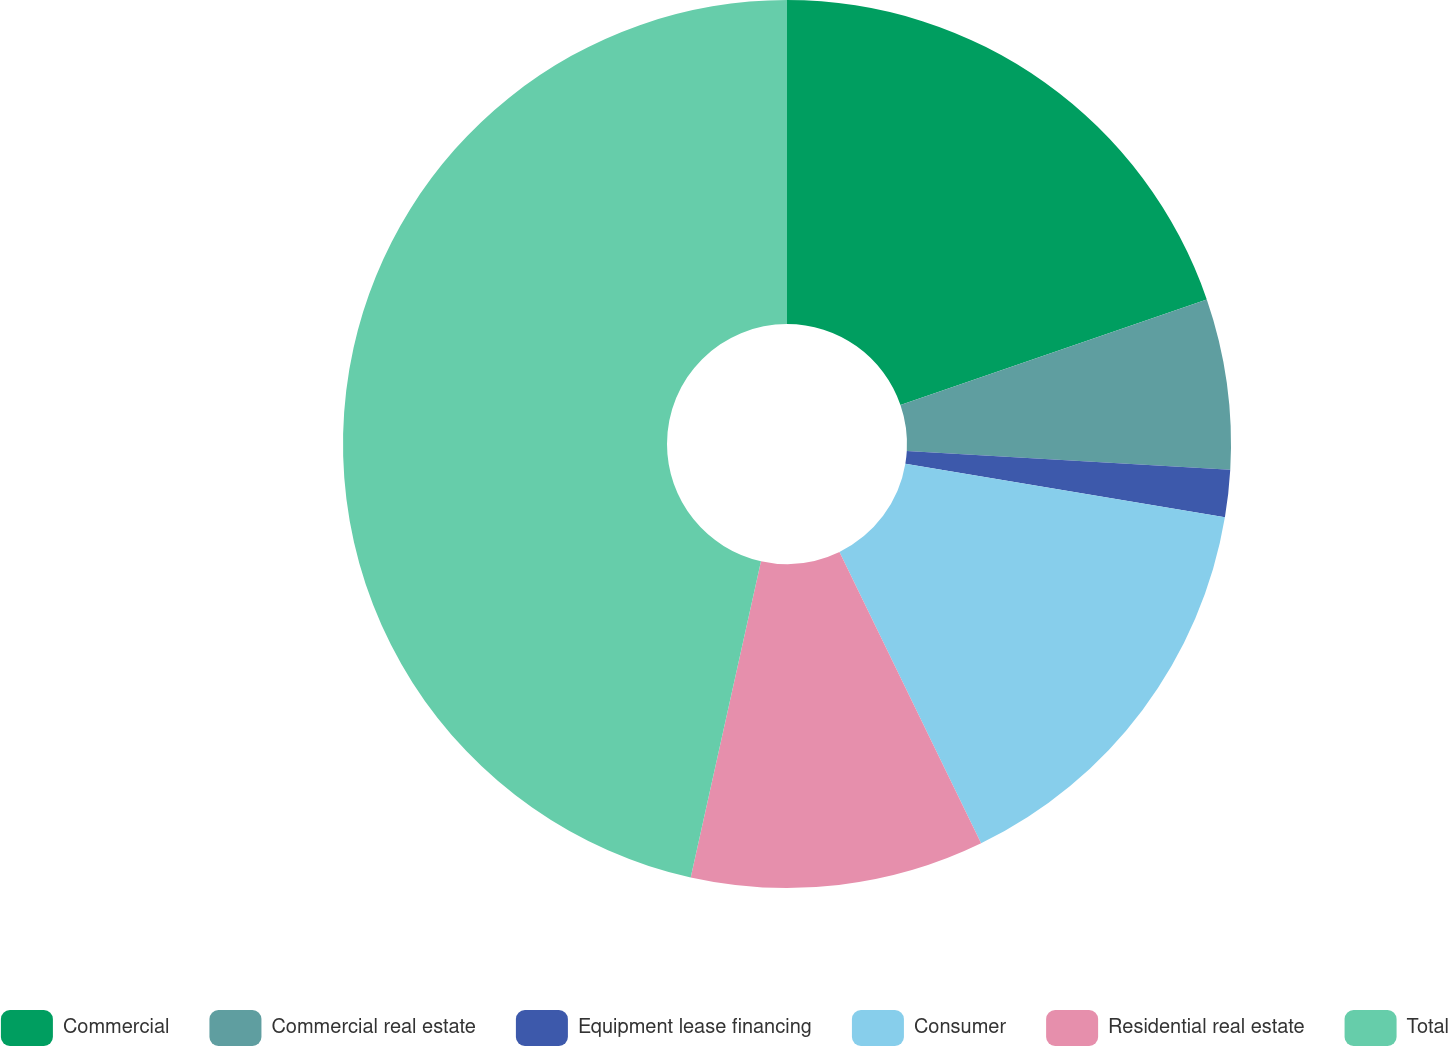Convert chart to OTSL. <chart><loc_0><loc_0><loc_500><loc_500><pie_chart><fcel>Commercial<fcel>Commercial real estate<fcel>Equipment lease financing<fcel>Consumer<fcel>Residential real estate<fcel>Total<nl><fcel>19.72%<fcel>6.2%<fcel>1.72%<fcel>15.16%<fcel>10.68%<fcel>46.52%<nl></chart> 